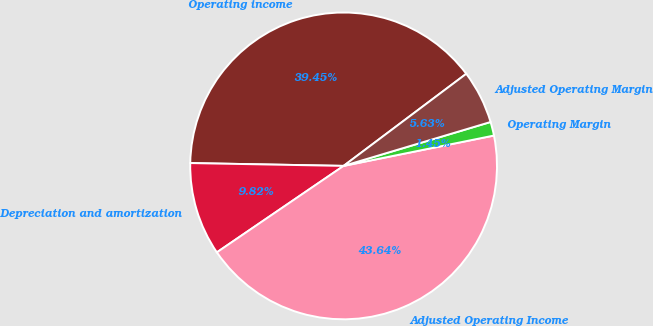Convert chart. <chart><loc_0><loc_0><loc_500><loc_500><pie_chart><fcel>Operating income<fcel>Depreciation and amortization<fcel>Adjusted Operating Income<fcel>Operating Margin<fcel>Adjusted Operating Margin<nl><fcel>39.45%<fcel>9.82%<fcel>43.64%<fcel>1.45%<fcel>5.63%<nl></chart> 